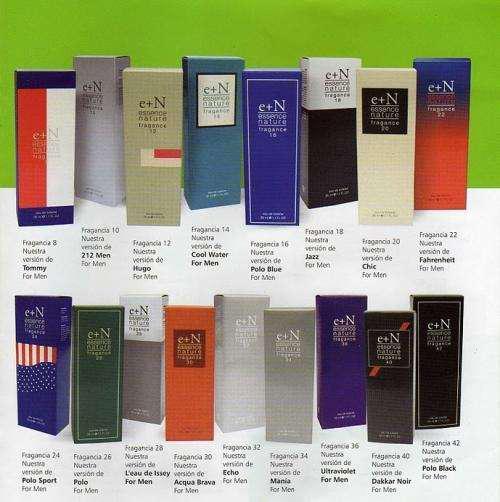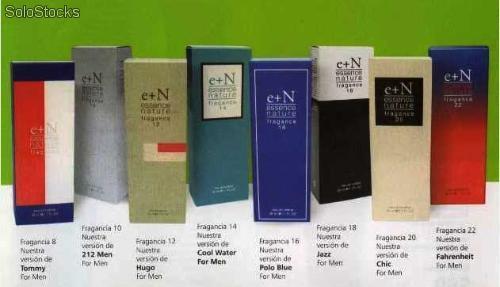The first image is the image on the left, the second image is the image on the right. For the images shown, is this caption "There is only one tube of product and its box in the image on the left." true? Answer yes or no. No. The first image is the image on the left, the second image is the image on the right. Examine the images to the left and right. Is the description "In one image, a single slender spray bottle stands next to a box with a woman's face on it." accurate? Answer yes or no. No. 